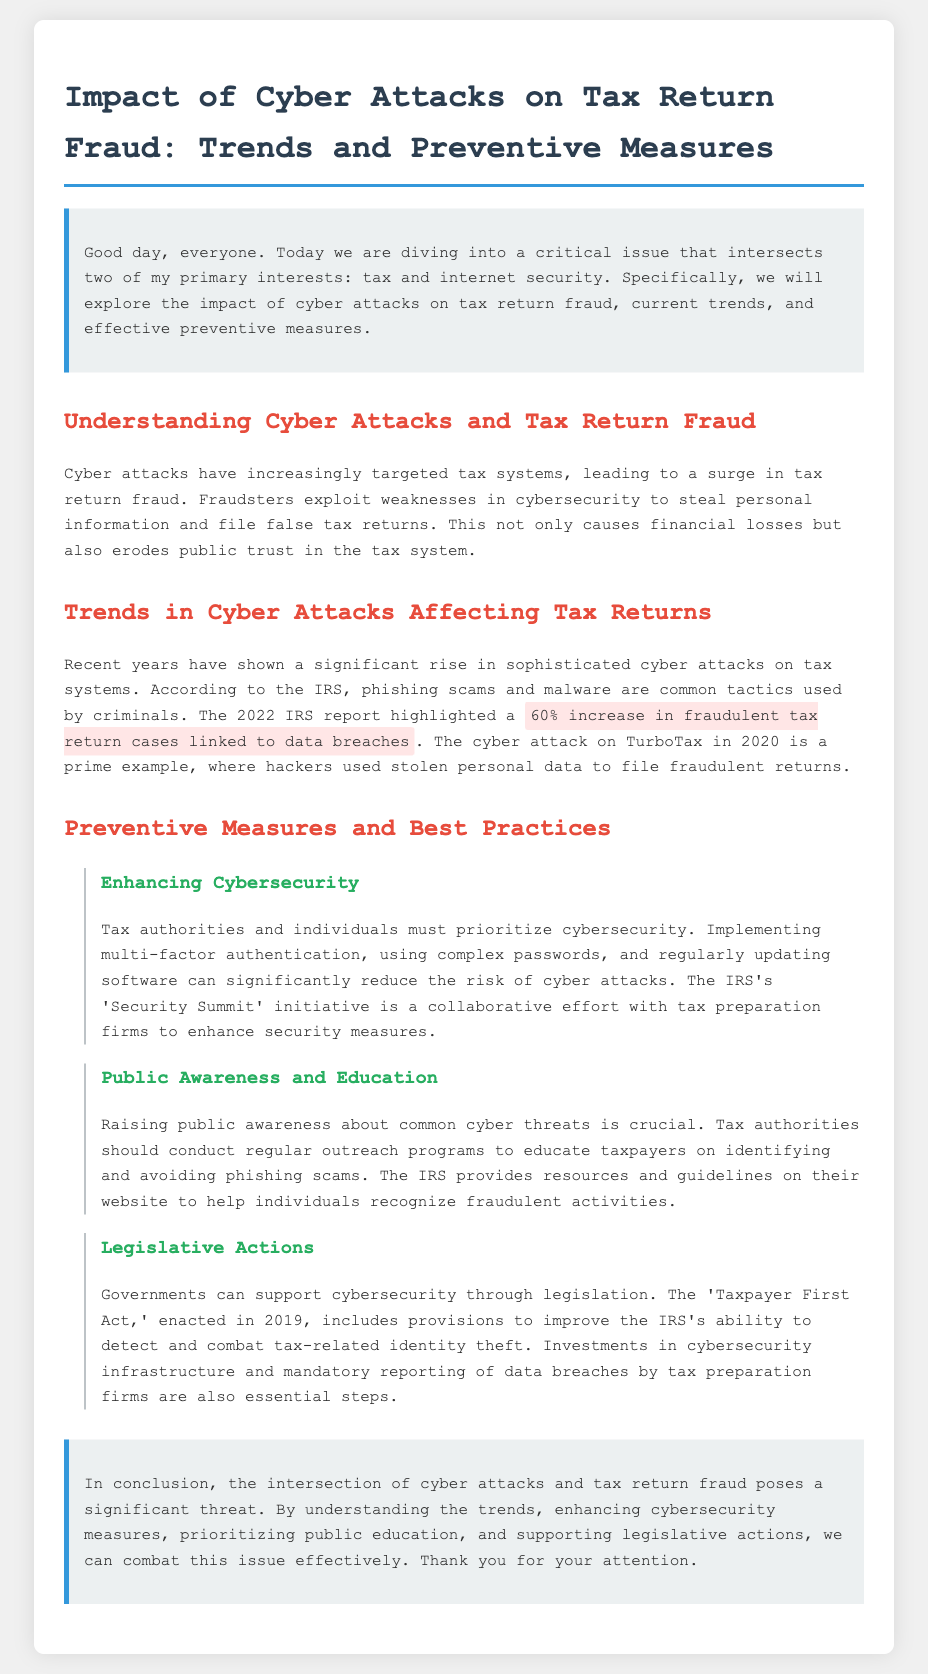what is the primary issue discussed in the document? The primary issue is the impact of cyber attacks on tax return fraud.
Answer: impact of cyber attacks on tax return fraud what was the percentage increase in fraudulent tax return cases linked to data breaches in 2022? The document states there was a 60% increase in fraudulent tax return cases linked to data breaches.
Answer: 60% what year did the IRS enact the 'Taxpayer First Act'? The 'Taxpayer First Act' was enacted in 2019.
Answer: 2019 which cyber attack incident is mentioned as an example in the document? The document mentions the cyber attack on TurboTax in 2020 as an example.
Answer: TurboTax what is one method recommended for enhancing cybersecurity? The document recommends implementing multi-factor authentication as a method for enhancing cybersecurity.
Answer: multi-factor authentication what initiative is mentioned as a collaborative effort to enhance security measures? The IRS's 'Security Summit' initiative is mentioned as a collaborative effort.
Answer: Security Summit why is public awareness important according to the document? Raising public awareness is crucial to educate taxpayers on identifying and avoiding phishing scams.
Answer: to educate taxpayers on identifying and avoiding phishing scams what role does government play in combating tax-related identity theft? The government supports cybersecurity through legislation, including improving the IRS's ability to detect identity theft.
Answer: legislation what is the main conclusion drawn in the document? The conclusion emphasizes the significance of understanding trends and enhancing measures to combat the issue effectively.
Answer: understanding trends and enhancing measures to combat the issue effectively 